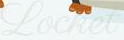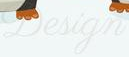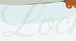What words are shown in these images in order, separated by a semicolon? Locket; Design; Loc 